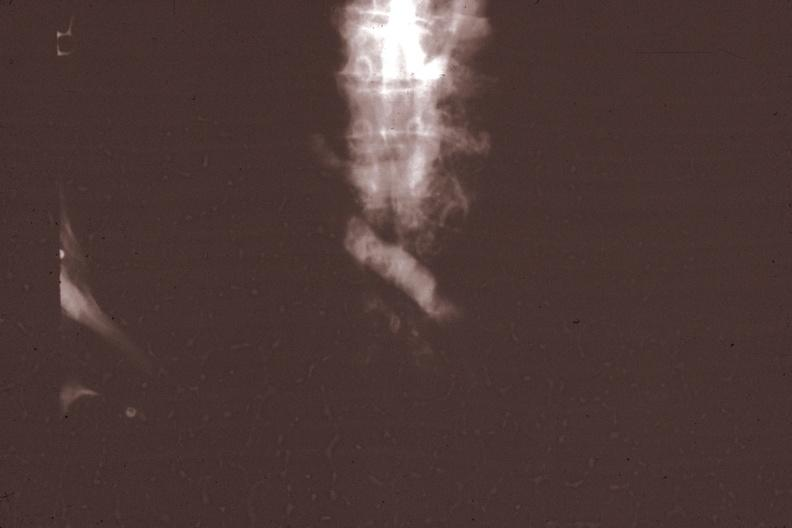what is present?
Answer the question using a single word or phrase. Thymus 